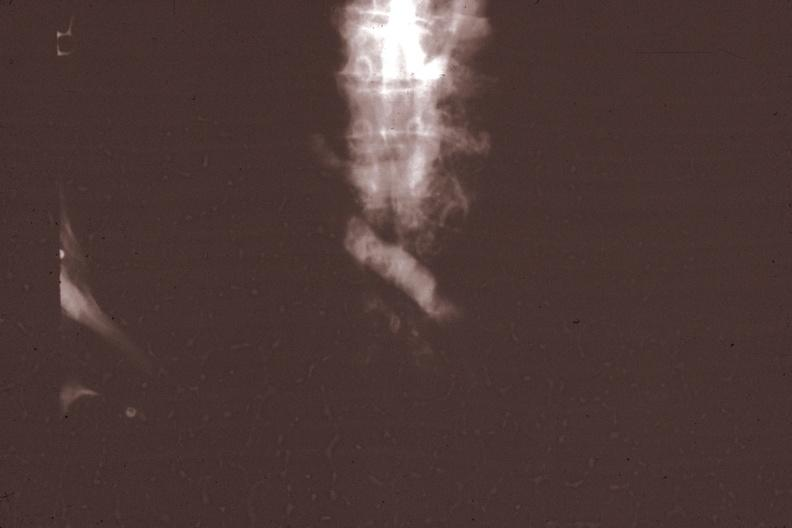what is present?
Answer the question using a single word or phrase. Thymus 